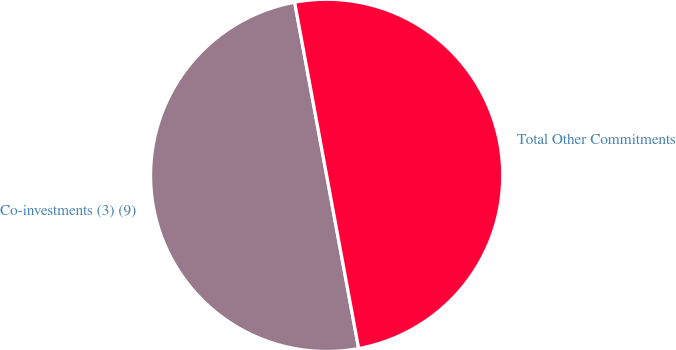Convert chart to OTSL. <chart><loc_0><loc_0><loc_500><loc_500><pie_chart><fcel>Co-investments (3) (9)<fcel>Total Other Commitments<nl><fcel>50.0%<fcel>50.0%<nl></chart> 